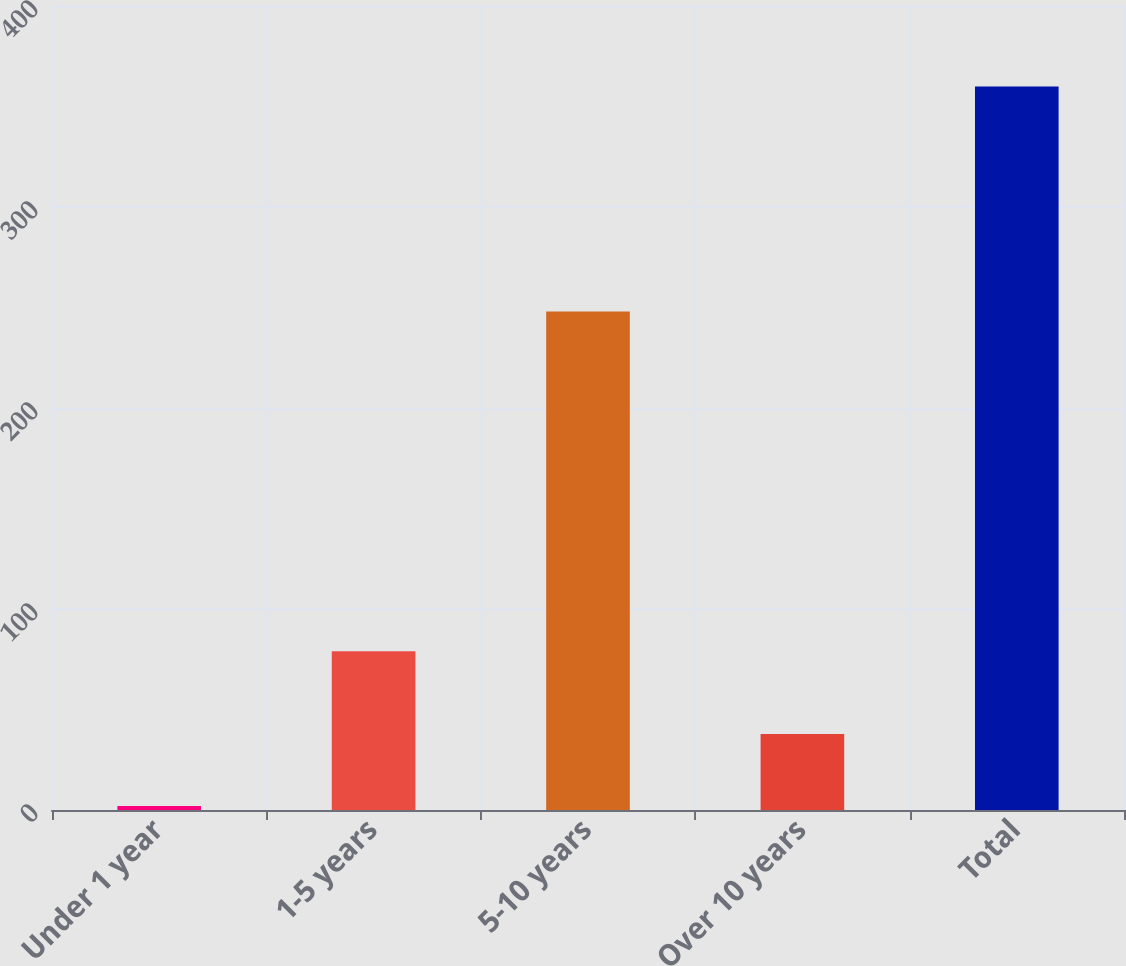Convert chart to OTSL. <chart><loc_0><loc_0><loc_500><loc_500><bar_chart><fcel>Under 1 year<fcel>1-5 years<fcel>5-10 years<fcel>Over 10 years<fcel>Total<nl><fcel>2<fcel>79<fcel>248<fcel>37.8<fcel>360<nl></chart> 